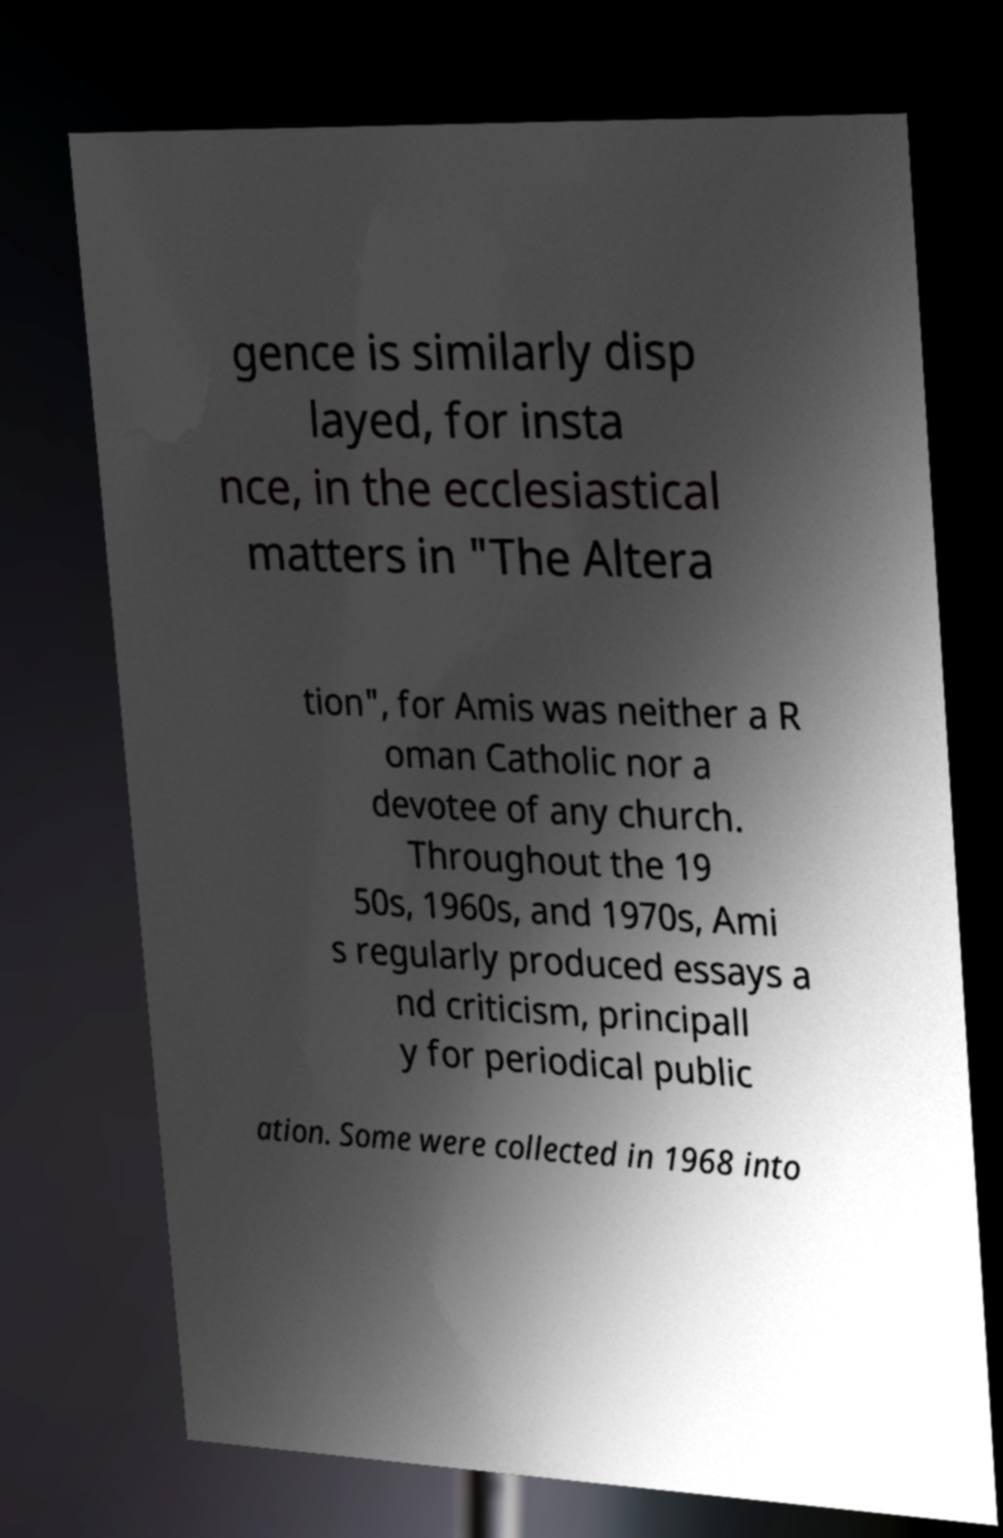Could you extract and type out the text from this image? gence is similarly disp layed, for insta nce, in the ecclesiastical matters in "The Altera tion", for Amis was neither a R oman Catholic nor a devotee of any church. Throughout the 19 50s, 1960s, and 1970s, Ami s regularly produced essays a nd criticism, principall y for periodical public ation. Some were collected in 1968 into 